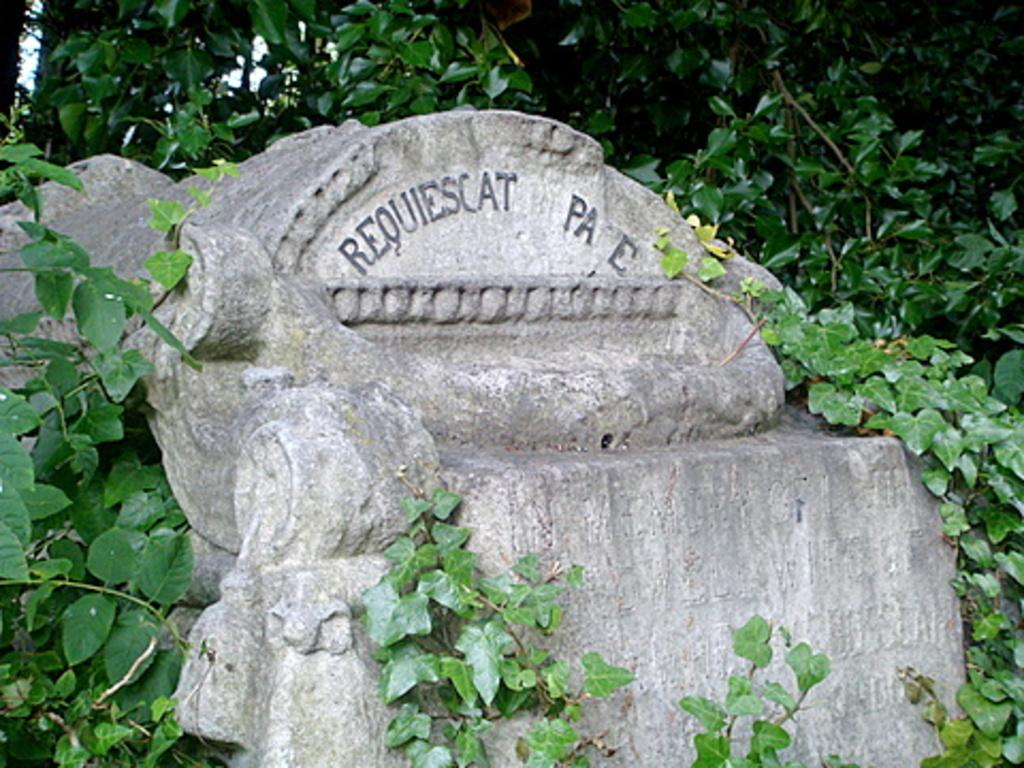What type of bench is in the image? There is a cement bench in the image. Where is the bench located? The bench is kept on the ground. What can be seen behind the bench? There are plants and trees behind the bench. How much glue is required to attach the bench to the ground in the image? The bench is not attached to the ground with glue; it is simply placed on the ground. 